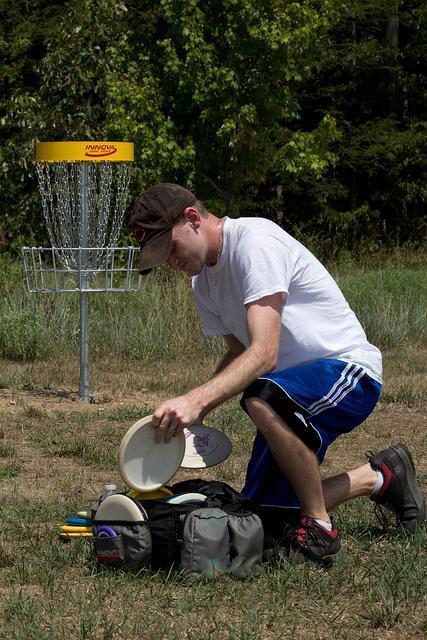How many umbrellas are open?
Give a very brief answer. 0. 